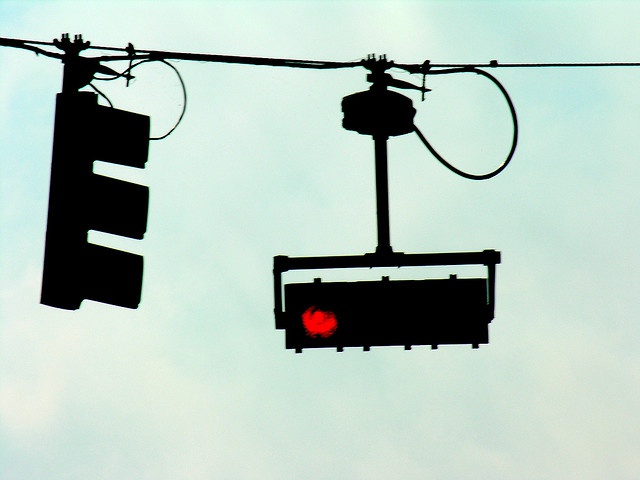Describe the objects in this image and their specific colors. I can see traffic light in lightblue, black, beige, red, and maroon tones and traffic light in lightblue, black, ivory, khaki, and olive tones in this image. 